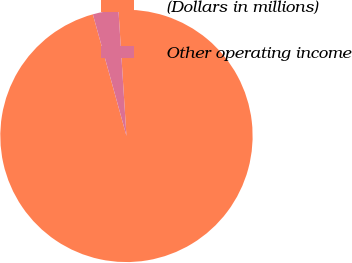<chart> <loc_0><loc_0><loc_500><loc_500><pie_chart><fcel>(Dollars in millions)<fcel>Other operating income<nl><fcel>96.72%<fcel>3.28%<nl></chart> 